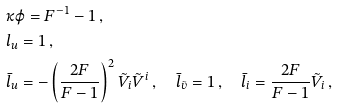<formula> <loc_0><loc_0><loc_500><loc_500>& \kappa \varphi = F ^ { - 1 } - 1 \, , \\ & l _ { u } = 1 \, , \\ & \bar { l } _ { u } = - \left ( \frac { 2 F } { F - 1 } \right ) ^ { 2 } \tilde { V } _ { i } \tilde { V } ^ { i } \, , \quad \bar { l } _ { \tilde { v } } = 1 \, , \quad \bar { l } _ { i } = \frac { 2 F } { F - 1 } \tilde { V } _ { i } \, ,</formula> 